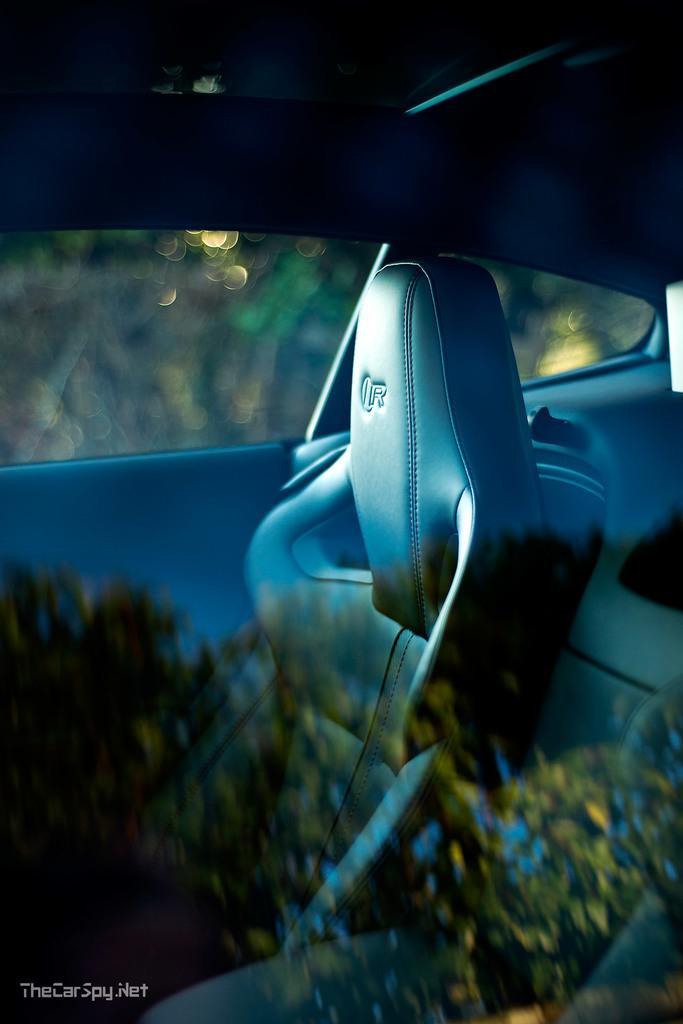Can you describe this image briefly? In this image we can see a car with some blurry background. 